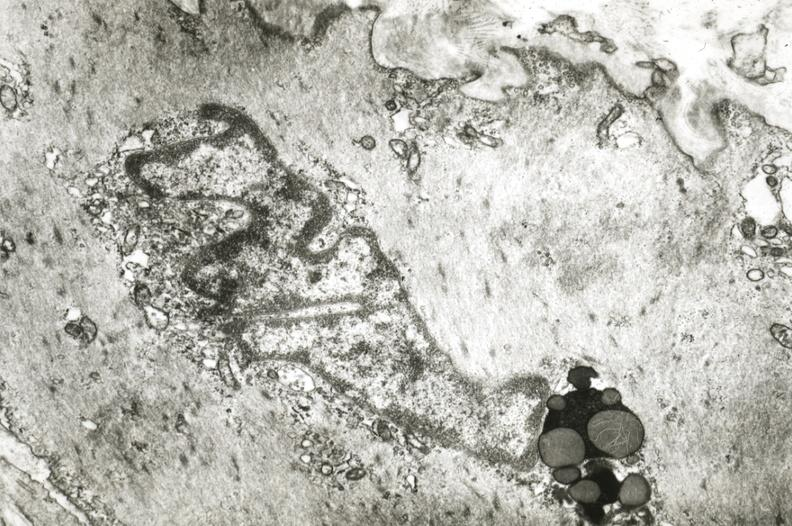where is this?
Answer the question using a single word or phrase. Vasculature 